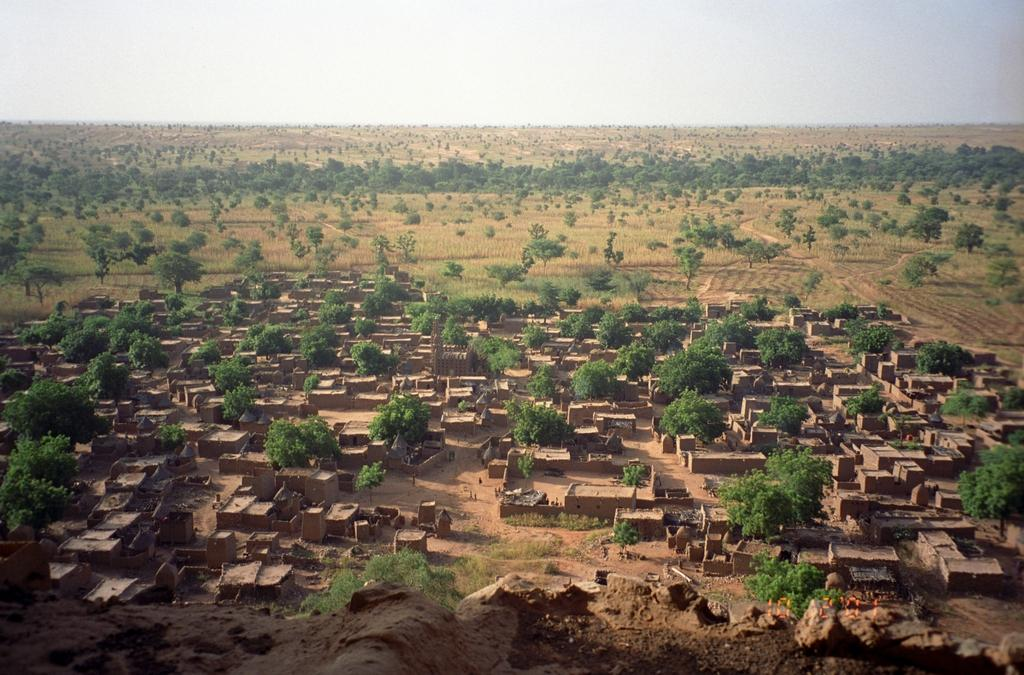What type of structures can be seen in the image? There are houses in the image. What type of vegetation is present in the image? There are trees and grass in the image. What can be seen in the background of the image? The sky is visible in the background of the image. What type of popcorn is being used to create the houses in the image? There is no popcorn present in the image; the houses are made of traditional building materials. In which direction is the image facing? The image does not have a specific direction, as it is a still image. 